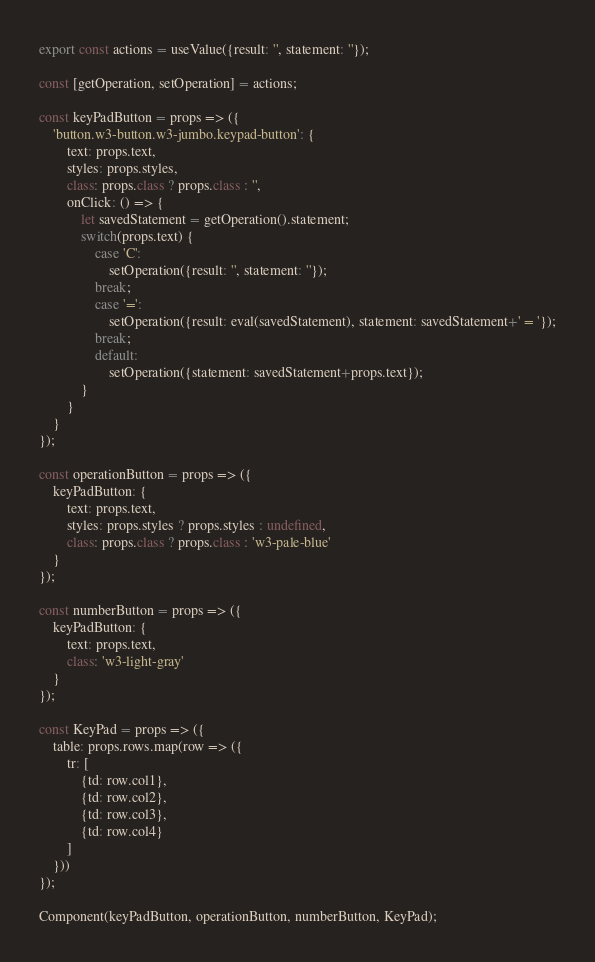Convert code to text. <code><loc_0><loc_0><loc_500><loc_500><_JavaScript_>export const actions = useValue({result: '', statement: ''});

const [getOperation, setOperation] = actions;

const keyPadButton = props => ({
    'button.w3-button.w3-jumbo.keypad-button': {
        text: props.text,
        styles: props.styles,
        class: props.class ? props.class : '',
        onClick: () => {
            let savedStatement = getOperation().statement;
            switch(props.text) {
                case 'C':
                    setOperation({result: '', statement: ''});
                break;
                case '=':
                    setOperation({result: eval(savedStatement), statement: savedStatement+' = '});
                break;
                default:
                    setOperation({statement: savedStatement+props.text});
            }
        }
    }
});

const operationButton = props => ({
    keyPadButton: {
        text: props.text,
        styles: props.styles ? props.styles : undefined,
        class: props.class ? props.class : 'w3-pale-blue'
    }
});

const numberButton = props => ({
    keyPadButton: {
        text: props.text,
        class: 'w3-light-gray'
    }
});

const KeyPad = props => ({
    table: props.rows.map(row => ({
        tr: [
            {td: row.col1},
            {td: row.col2},
            {td: row.col3},
            {td: row.col4}
        ]
    }))
});

Component(keyPadButton, operationButton, numberButton, KeyPad);</code> 